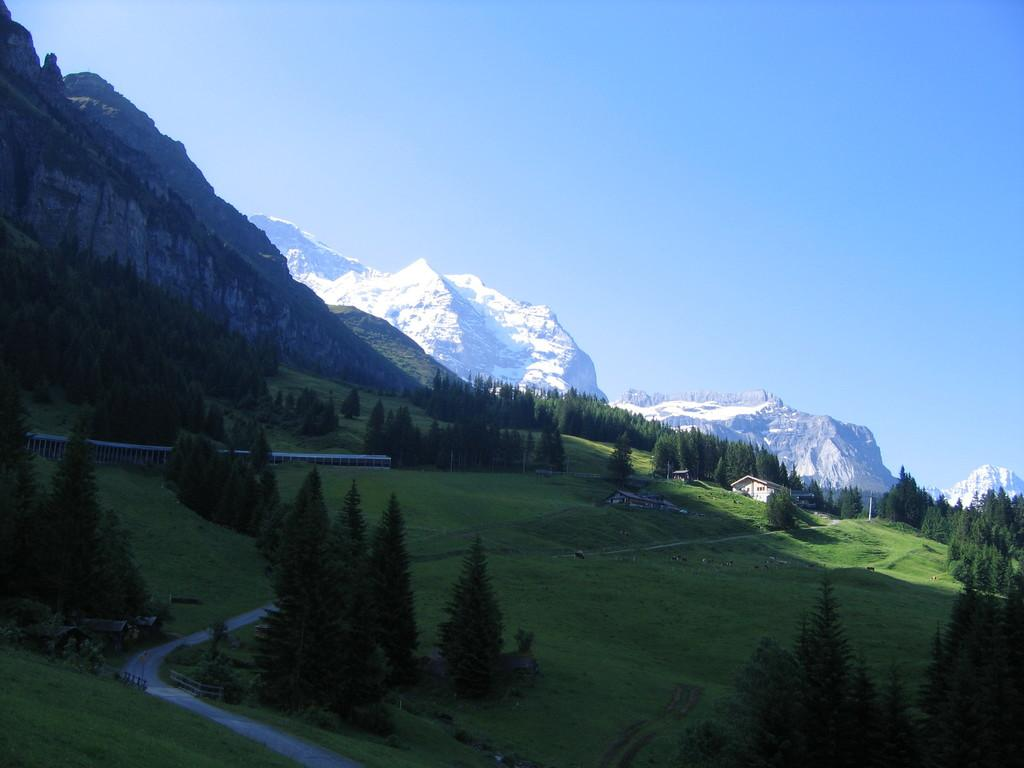What type of surface can be seen in the image? There is a road in the image. What type of vegetation is present in the image? There is grass and trees in the image. What type of structure is visible in the image? There is a building in the image, and it is cream in color. What can be seen in the background of the image? There are mountains visible in the background of the image, and there is snow on the mountains. What part of the natural environment is visible in the image? The sky is visible in the image. Can you see a wound on the building in the image? There is no wound present on the building in the image. What type of seat is visible in the image? There is no seat present in the image. 